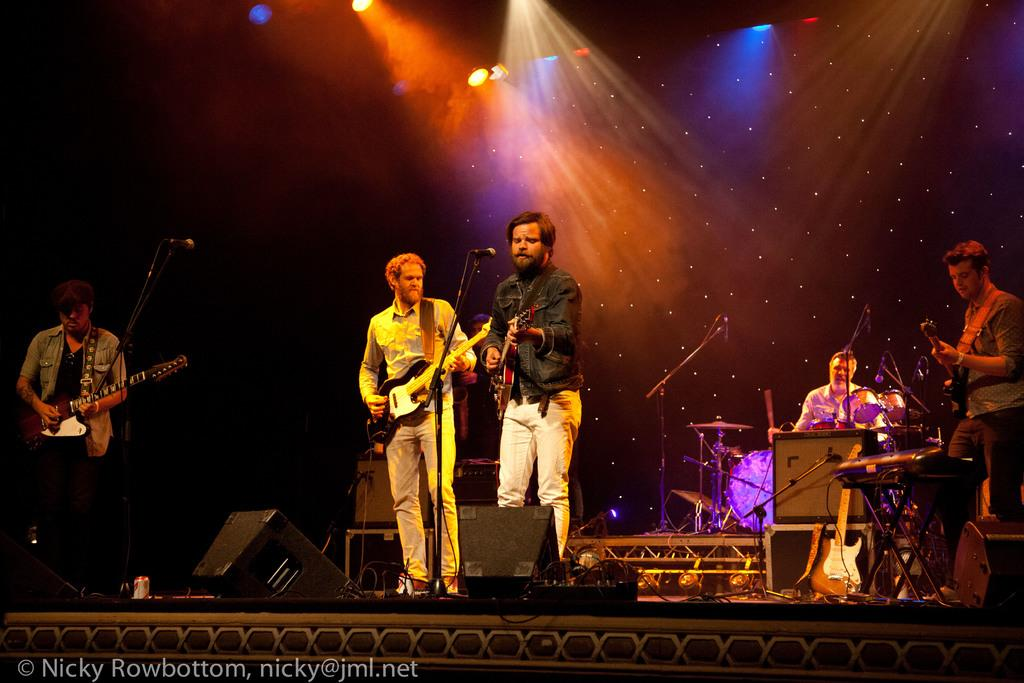What are the people in the image doing? The people in the image are standing and playing musical instruments. What specific instruments are the people playing? The people are holding guitars and playing drums. What equipment is present on the stage? There are speakers on the stage. What type of cover is being used to protect the guitars from milk in the image? There is no cover or milk present in the image; the people are holding guitars and playing them. Is there a knife visible in the image? No, there is no knife present in the image. 